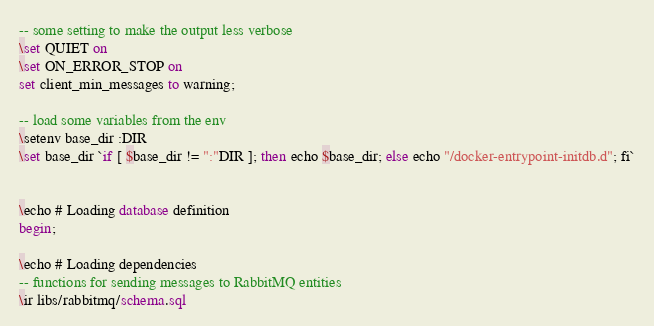<code> <loc_0><loc_0><loc_500><loc_500><_SQL_>-- some setting to make the output less verbose
\set QUIET on
\set ON_ERROR_STOP on
set client_min_messages to warning;

-- load some variables from the env
\setenv base_dir :DIR
\set base_dir `if [ $base_dir != ":"DIR ]; then echo $base_dir; else echo "/docker-entrypoint-initdb.d"; fi`


\echo # Loading database definition
begin;

\echo # Loading dependencies
-- functions for sending messages to RabbitMQ entities
\ir libs/rabbitmq/schema.sql
</code> 